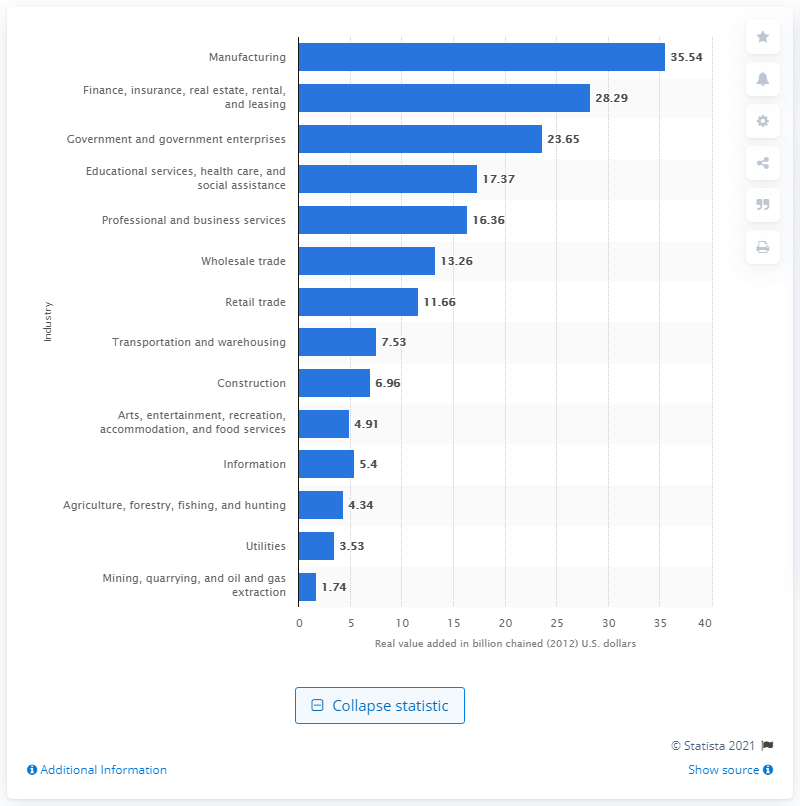Which industry had the second-highest contribution to Kentucky's GDP in 2020? The industry with the second-highest contribution to Kentucky's GDP in 2020 was the Finance, insurance, real estate, rental, and leasing sector, with 28.29 billion chained 2012 U.S. dollars. 